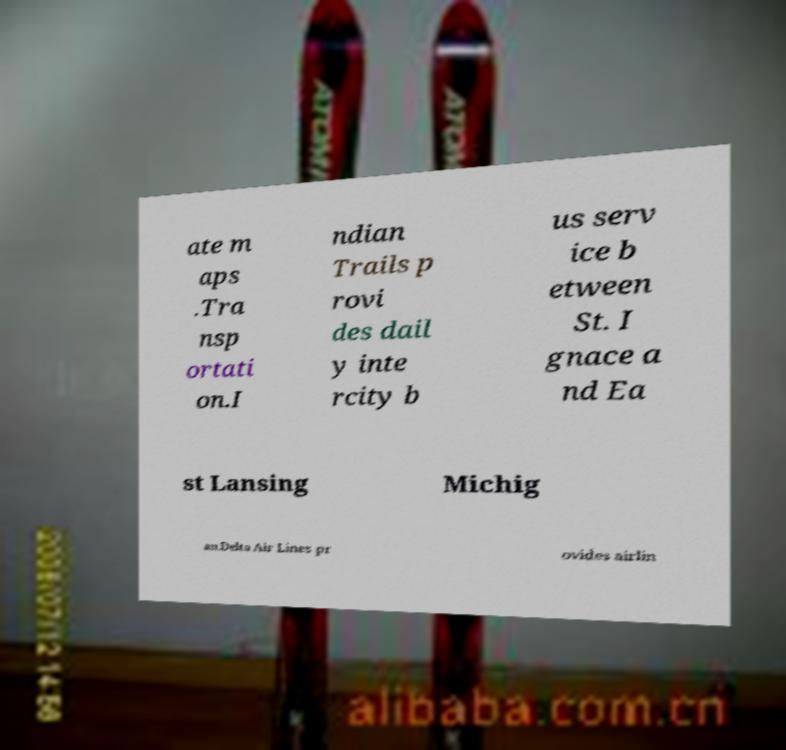Could you extract and type out the text from this image? ate m aps .Tra nsp ortati on.I ndian Trails p rovi des dail y inte rcity b us serv ice b etween St. I gnace a nd Ea st Lansing Michig an.Delta Air Lines pr ovides airlin 